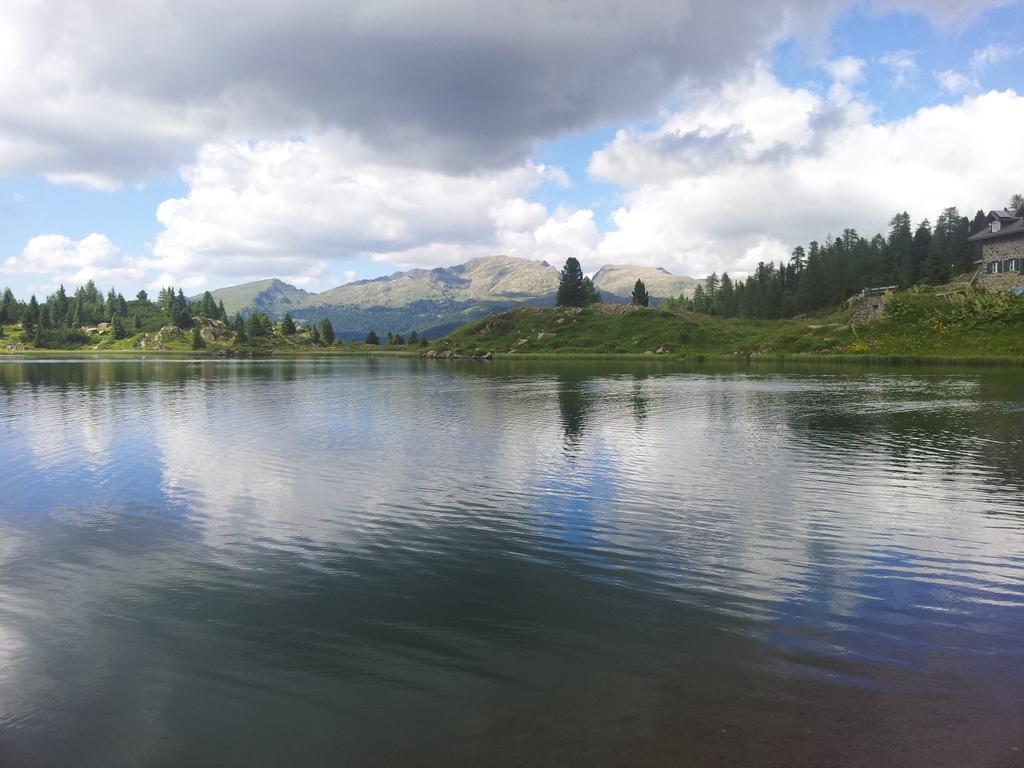Describe this image in one or two sentences. In the picture we can see a water and far away from it, we can see some grass surface on the hills with some rocks, trees and some hills and behind it we can see a sky with clouds. 